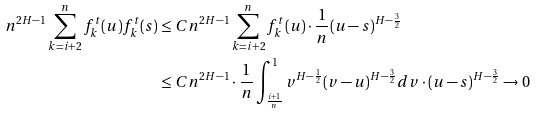<formula> <loc_0><loc_0><loc_500><loc_500>n ^ { 2 H - 1 } \sum _ { k = i + 2 } ^ { n } f _ { k } ^ { t } ( u ) f _ { k } ^ { t } ( s ) & \leq C n ^ { 2 H - 1 } \sum _ { k = i + 2 } ^ { n } f _ { k } ^ { t } ( u ) \cdot \frac { 1 } { n } ( u - s ) ^ { H - \frac { 3 } { 2 } } \\ & \leq C n ^ { 2 H - 1 } \cdot \frac { 1 } { n } \int _ { \frac { i + 1 } { n } } ^ { 1 } v ^ { H - \frac { 1 } { 2 } } ( v - u ) ^ { H - \frac { 3 } { 2 } } d v \cdot ( u - s ) ^ { H - \frac { 3 } { 2 } } \rightarrow 0</formula> 